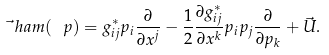Convert formula to latex. <formula><loc_0><loc_0><loc_500><loc_500>\vec { \ } h a m ( \ p ) = g ^ { * } _ { i j } p _ { i } \frac { \partial } { \partial x ^ { j } } - \frac { 1 } { 2 } \frac { \partial g ^ { * } _ { i j } } { \partial x ^ { k } } p _ { i } p _ { j } \frac { \partial } { \partial p _ { k } } + \vec { U } .</formula> 